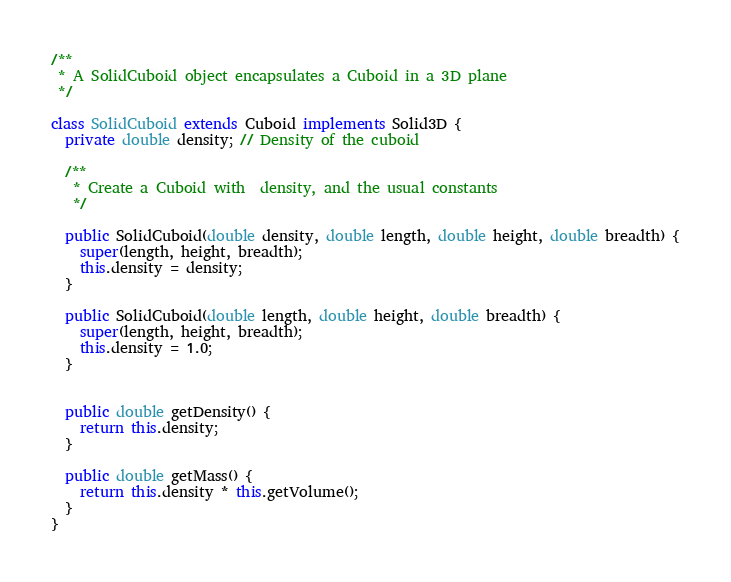<code> <loc_0><loc_0><loc_500><loc_500><_Java_>
/**
 * A SolidCuboid object encapsulates a Cuboid in a 3D plane
 */

class SolidCuboid extends Cuboid implements Solid3D {
  private double density; // Density of the cuboid
  
  /**
   * Create a Cuboid with  density, and the usual constants
   */

  public SolidCuboid(double density, double length, double height, double breadth) {
    super(length, height, breadth);
    this.density = density;
  }

  public SolidCuboid(double length, double height, double breadth) {
    super(length, height, breadth);
    this.density = 1.0;
  }


  public double getDensity() {
    return this.density;
  }

  public double getMass() {
    return this.density * this.getVolume();
  }
}


</code> 